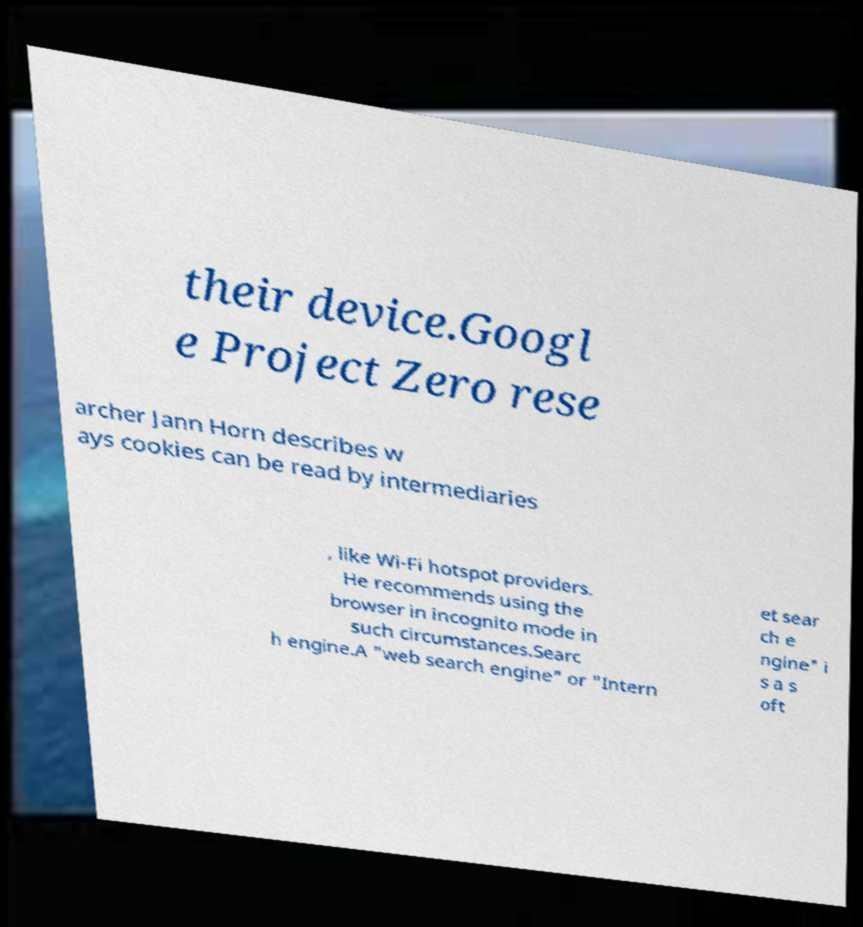Could you extract and type out the text from this image? their device.Googl e Project Zero rese archer Jann Horn describes w ays cookies can be read by intermediaries , like Wi-Fi hotspot providers. He recommends using the browser in incognito mode in such circumstances.Searc h engine.A "web search engine" or "Intern et sear ch e ngine" i s a s oft 